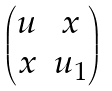Convert formula to latex. <formula><loc_0><loc_0><loc_500><loc_500>\begin{pmatrix} u & x \\ x & u _ { 1 } \end{pmatrix}</formula> 